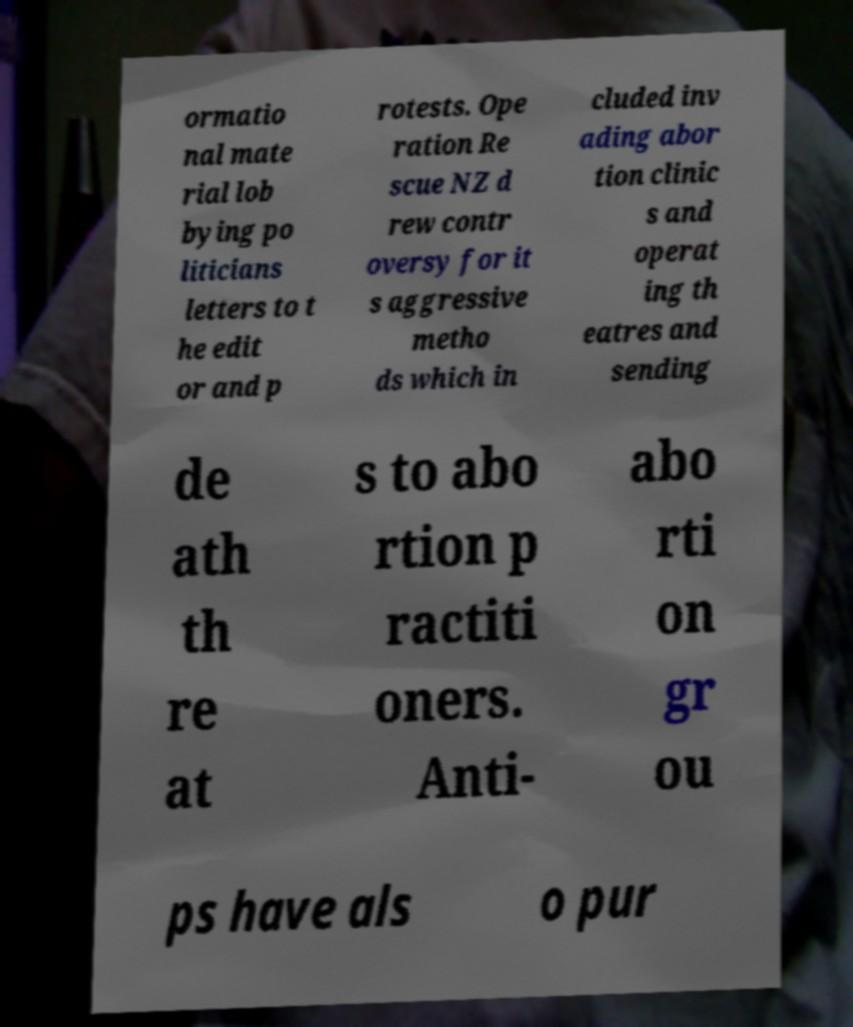What messages or text are displayed in this image? I need them in a readable, typed format. ormatio nal mate rial lob bying po liticians letters to t he edit or and p rotests. Ope ration Re scue NZ d rew contr oversy for it s aggressive metho ds which in cluded inv ading abor tion clinic s and operat ing th eatres and sending de ath th re at s to abo rtion p ractiti oners. Anti- abo rti on gr ou ps have als o pur 